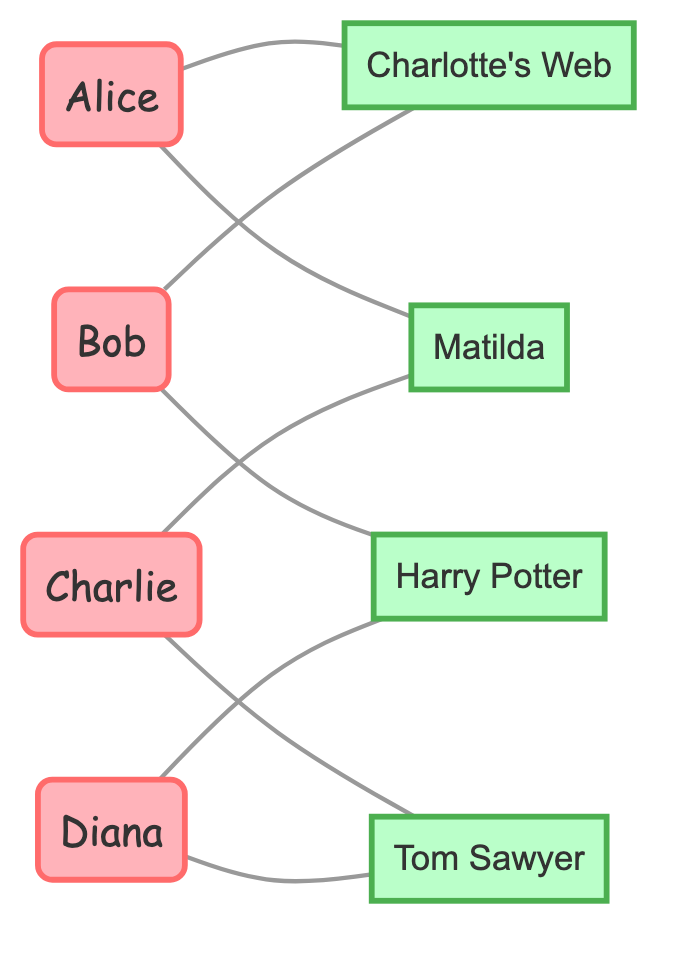What is the total number of students in the diagram? The diagram lists four distinct names under the "students" category: Alice, Bob, Charlie, and Diana. Therefore, counting these names gives a total of 4 students.
Answer: 4 How many books are represented in the diagram? The diagram displays a list of four specific titles under the "books" category: Charlotte's Web, Harry Potter and the Sorcerer's Stone, Matilda, and The Adventures of Tom Sawyer. Counting these titles reveals a total of 4 books.
Answer: 4 Which student is connected to "Charlotte's Web"? In the connections section of the diagram, it is noted that Alice and Bob are both linked to "Charlotte's Web." Therefore, the response includes Alice and Bob as the students connected to this book.
Answer: Alice, Bob How many connections does Bob have in the diagram? By examining the connections for Bob, we see he has two distinct connections: one to "Harry Potter and the Sorcerer's Stone" and another to "Charlotte's Web." Thus, counting these connections shows Bob has 2 connections.
Answer: 2 Which book is connected to both Charlie and Diana? Observing the connections made by Charlie and Diana, we note that "The Adventures of Tom Sawyer" links both students. Therefore, the answer is the title of that shared book.
Answer: The Adventures of Tom Sawyer Are there any books that have more than one student connected to them? Analyzing the connections, both "Charlotte's Web" (connected to Alice and Bob) and "Harry Potter and the Sorcerer's Stone" (connected to Bob and Diana) have multiple students connected. Thus, there are books with more than one student connection.
Answer: Yes How many edges are present in the diagram? Each connection listed represents an edge. Counting all connections given in the data, we find a total of 8 individual connections that can be designated as edges in the graph.
Answer: 8 If Alice exchanges her books, how many distinct books does she have access to? Alice is linked to two books: "Charlotte's Web" and "Matilda." However, considering that she can also access the books owned by other students connected to her, she can directly access an additional book from Bob (Charlotte's Web) and one from Charlie (Matilda) or Diana (Harry Potter and the Sorcerer's Stone). Thus, by combining, Alice can effectively access a total of 3 distinct titles.
Answer: 3 